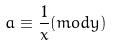Convert formula to latex. <formula><loc_0><loc_0><loc_500><loc_500>a \equiv \frac { 1 } { x } ( m o d y )</formula> 